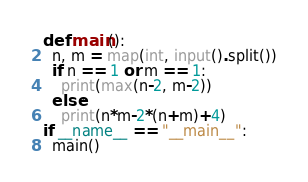<code> <loc_0><loc_0><loc_500><loc_500><_Python_>def main():
  n, m = map(int, input().split())
  if n == 1 or m == 1:
    print(max(n-2, m-2))
  else:
    print(n*m-2*(n+m)+4)
if __name__ == "__main__":
  main()</code> 